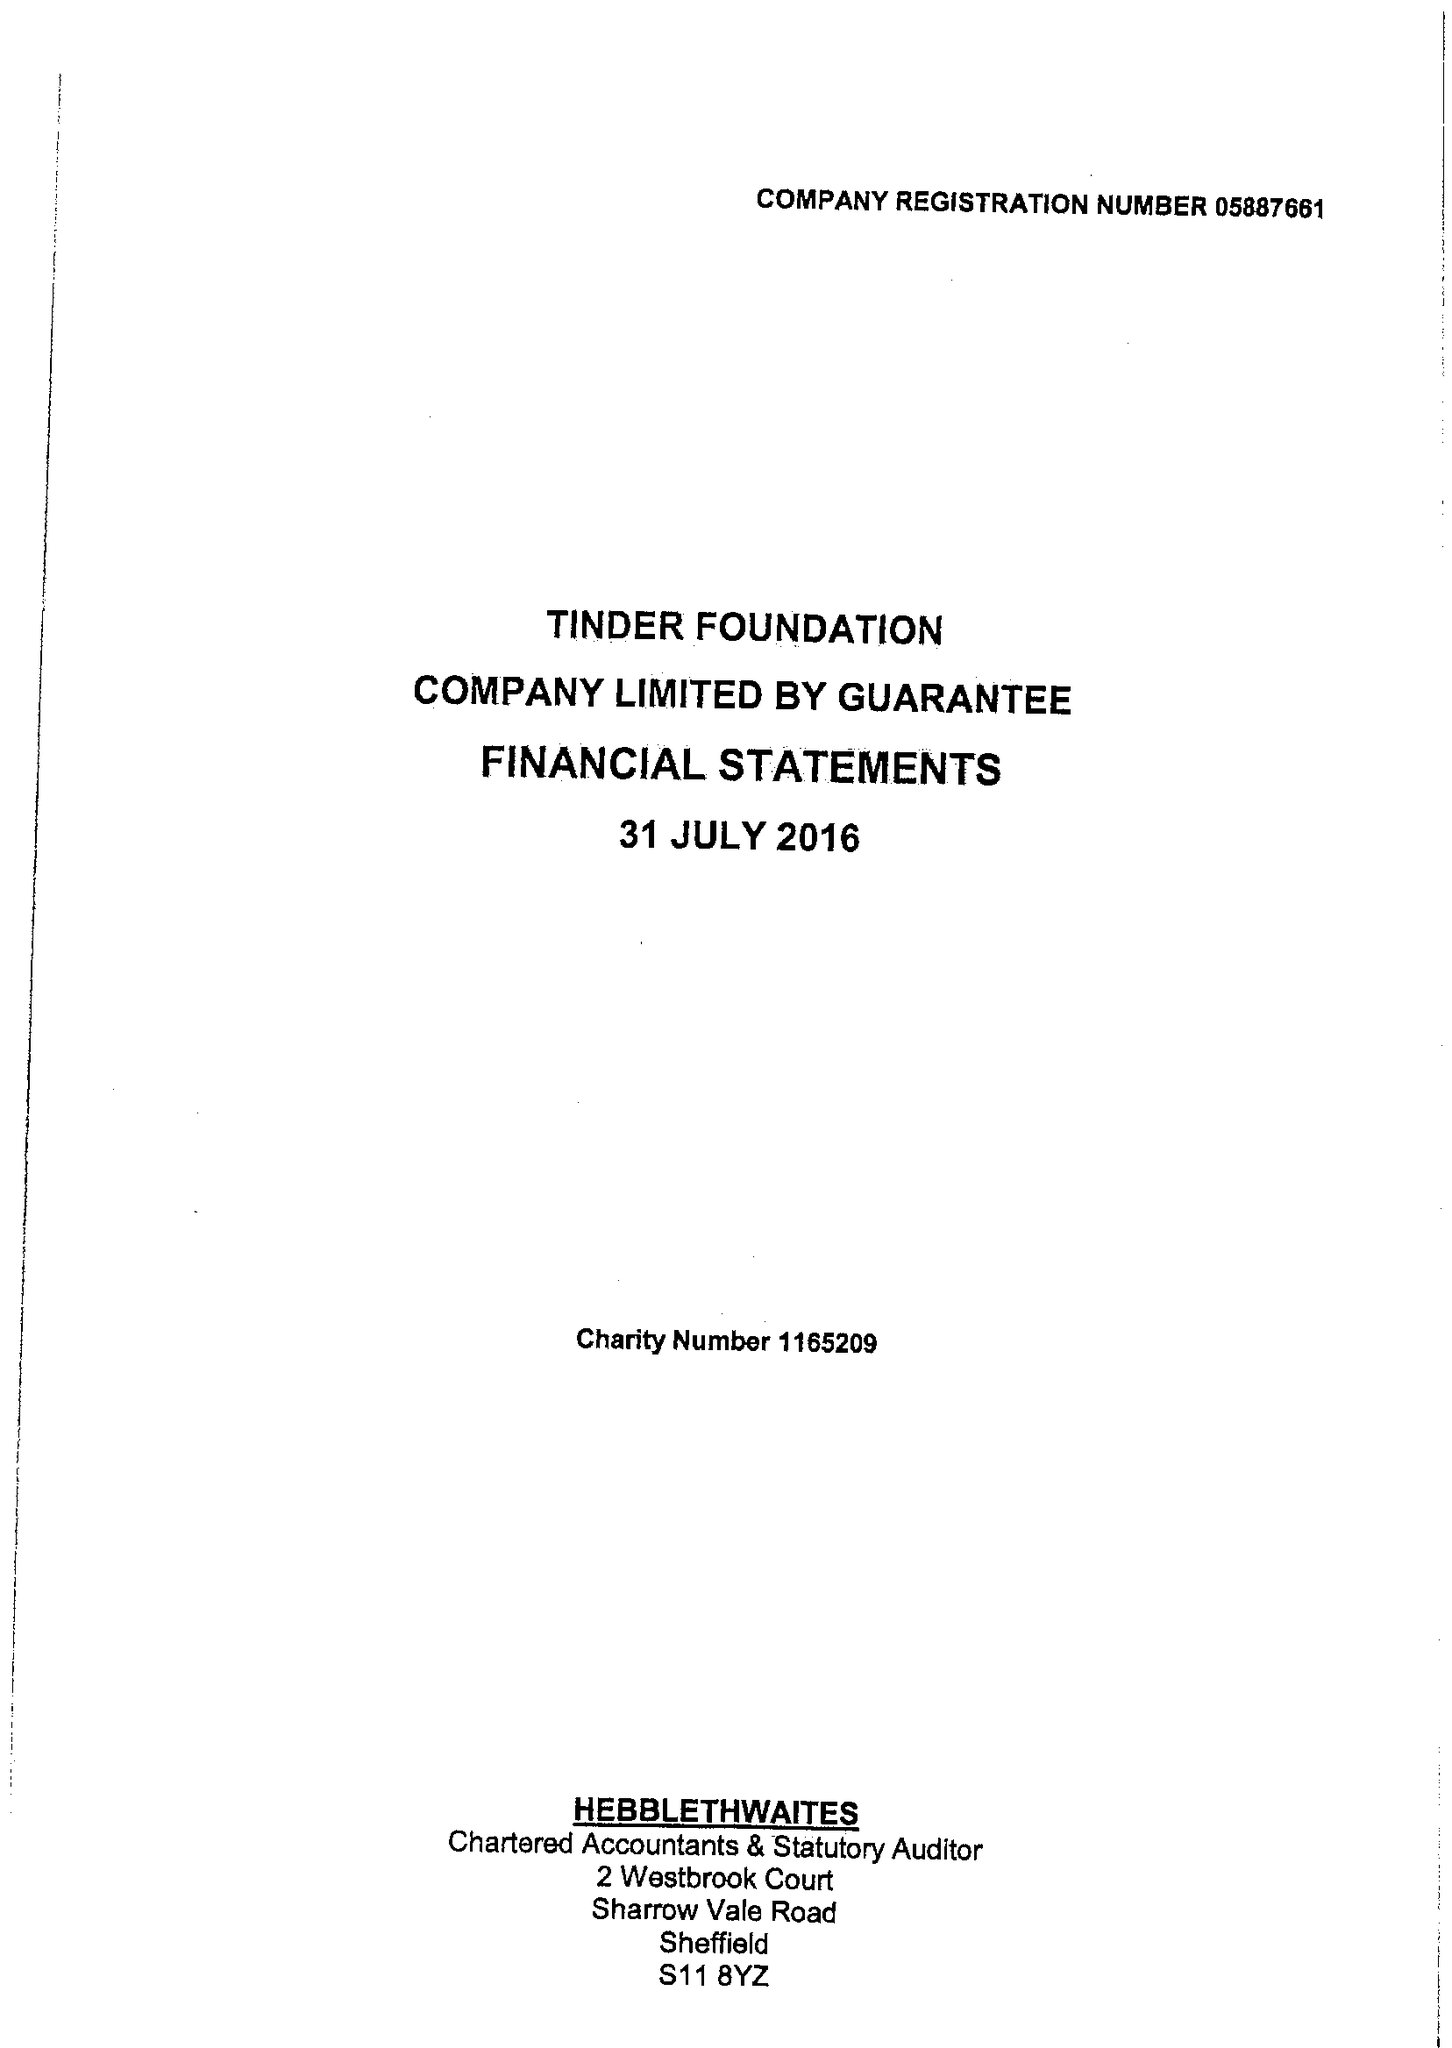What is the value for the address__post_town?
Answer the question using a single word or phrase. SHEFFIELD 